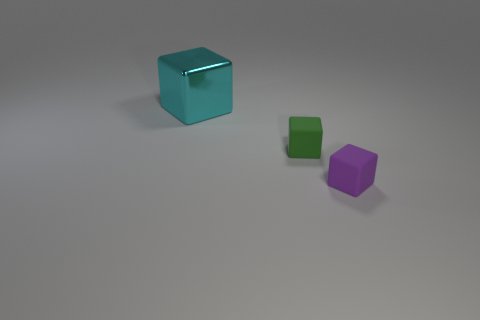Add 1 small green cubes. How many objects exist? 4 Subtract all purple matte cubes. Subtract all big brown rubber balls. How many objects are left? 2 Add 2 cyan shiny objects. How many cyan shiny objects are left? 3 Add 2 small green blocks. How many small green blocks exist? 3 Subtract 1 cyan blocks. How many objects are left? 2 